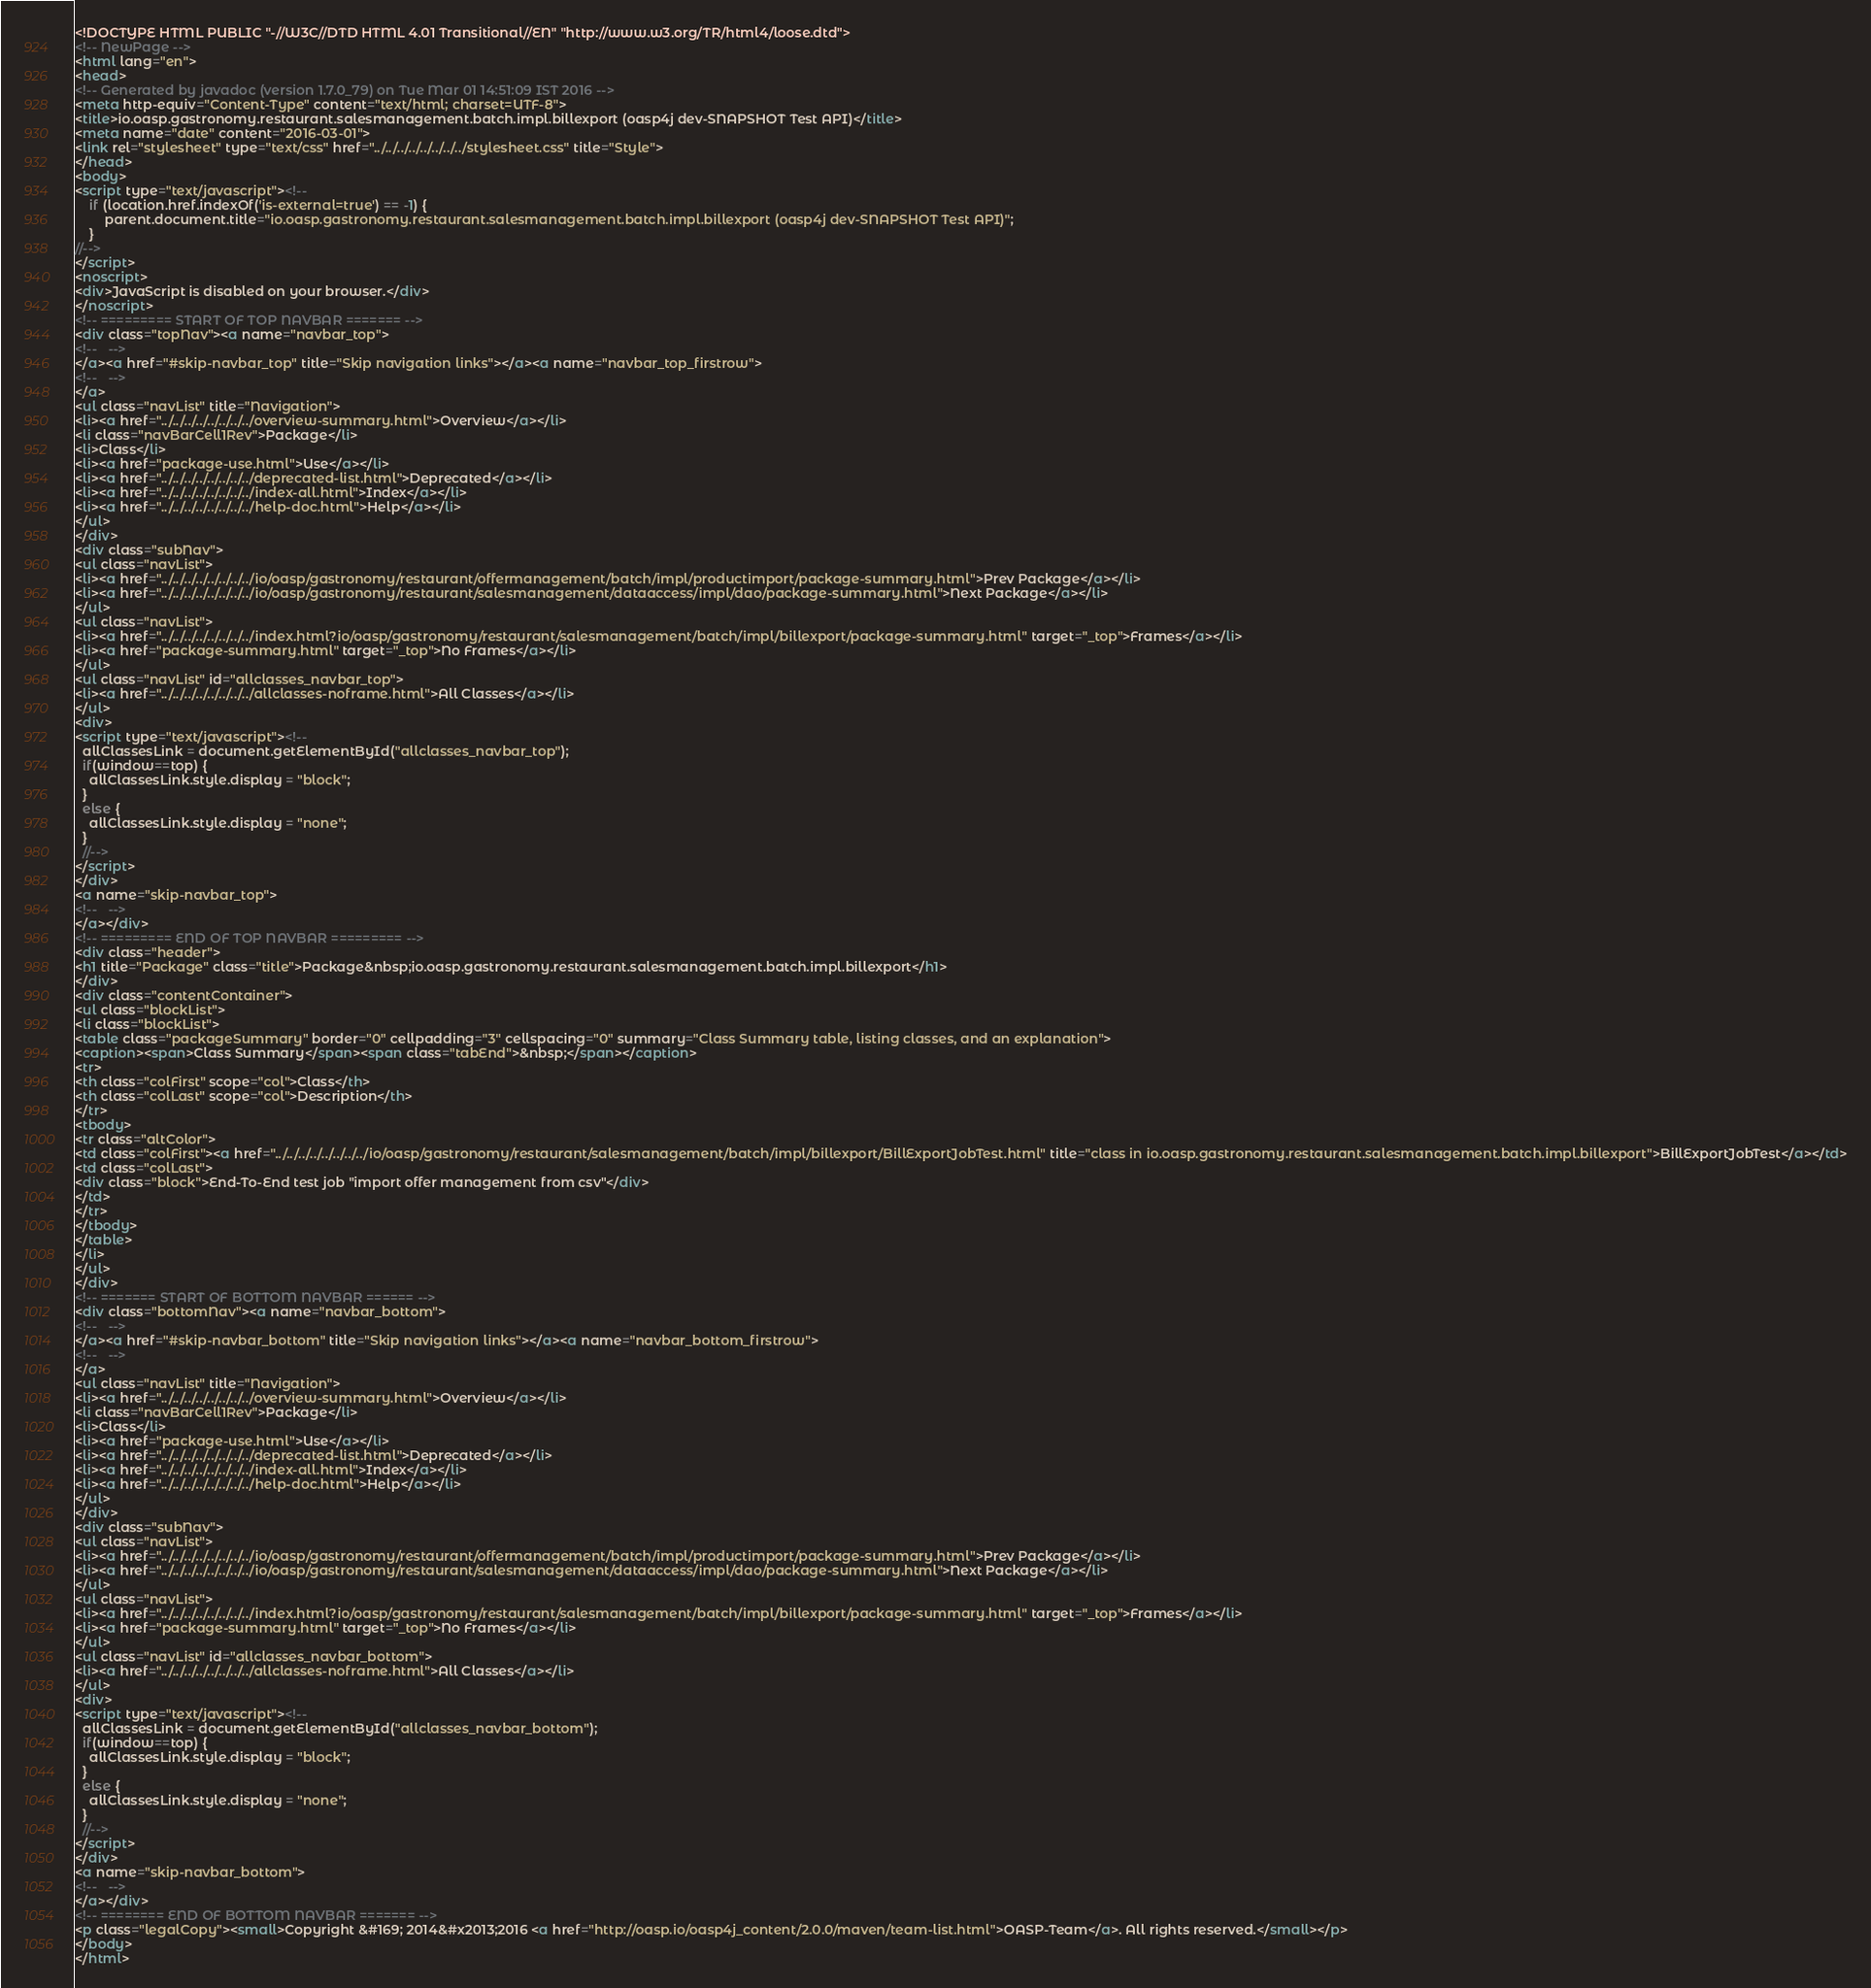<code> <loc_0><loc_0><loc_500><loc_500><_HTML_><!DOCTYPE HTML PUBLIC "-//W3C//DTD HTML 4.01 Transitional//EN" "http://www.w3.org/TR/html4/loose.dtd">
<!-- NewPage -->
<html lang="en">
<head>
<!-- Generated by javadoc (version 1.7.0_79) on Tue Mar 01 14:51:09 IST 2016 -->
<meta http-equiv="Content-Type" content="text/html; charset=UTF-8">
<title>io.oasp.gastronomy.restaurant.salesmanagement.batch.impl.billexport (oasp4j dev-SNAPSHOT Test API)</title>
<meta name="date" content="2016-03-01">
<link rel="stylesheet" type="text/css" href="../../../../../../../../stylesheet.css" title="Style">
</head>
<body>
<script type="text/javascript"><!--
    if (location.href.indexOf('is-external=true') == -1) {
        parent.document.title="io.oasp.gastronomy.restaurant.salesmanagement.batch.impl.billexport (oasp4j dev-SNAPSHOT Test API)";
    }
//-->
</script>
<noscript>
<div>JavaScript is disabled on your browser.</div>
</noscript>
<!-- ========= START OF TOP NAVBAR ======= -->
<div class="topNav"><a name="navbar_top">
<!--   -->
</a><a href="#skip-navbar_top" title="Skip navigation links"></a><a name="navbar_top_firstrow">
<!--   -->
</a>
<ul class="navList" title="Navigation">
<li><a href="../../../../../../../../overview-summary.html">Overview</a></li>
<li class="navBarCell1Rev">Package</li>
<li>Class</li>
<li><a href="package-use.html">Use</a></li>
<li><a href="../../../../../../../../deprecated-list.html">Deprecated</a></li>
<li><a href="../../../../../../../../index-all.html">Index</a></li>
<li><a href="../../../../../../../../help-doc.html">Help</a></li>
</ul>
</div>
<div class="subNav">
<ul class="navList">
<li><a href="../../../../../../../../io/oasp/gastronomy/restaurant/offermanagement/batch/impl/productimport/package-summary.html">Prev Package</a></li>
<li><a href="../../../../../../../../io/oasp/gastronomy/restaurant/salesmanagement/dataaccess/impl/dao/package-summary.html">Next Package</a></li>
</ul>
<ul class="navList">
<li><a href="../../../../../../../../index.html?io/oasp/gastronomy/restaurant/salesmanagement/batch/impl/billexport/package-summary.html" target="_top">Frames</a></li>
<li><a href="package-summary.html" target="_top">No Frames</a></li>
</ul>
<ul class="navList" id="allclasses_navbar_top">
<li><a href="../../../../../../../../allclasses-noframe.html">All Classes</a></li>
</ul>
<div>
<script type="text/javascript"><!--
  allClassesLink = document.getElementById("allclasses_navbar_top");
  if(window==top) {
    allClassesLink.style.display = "block";
  }
  else {
    allClassesLink.style.display = "none";
  }
  //-->
</script>
</div>
<a name="skip-navbar_top">
<!--   -->
</a></div>
<!-- ========= END OF TOP NAVBAR ========= -->
<div class="header">
<h1 title="Package" class="title">Package&nbsp;io.oasp.gastronomy.restaurant.salesmanagement.batch.impl.billexport</h1>
</div>
<div class="contentContainer">
<ul class="blockList">
<li class="blockList">
<table class="packageSummary" border="0" cellpadding="3" cellspacing="0" summary="Class Summary table, listing classes, and an explanation">
<caption><span>Class Summary</span><span class="tabEnd">&nbsp;</span></caption>
<tr>
<th class="colFirst" scope="col">Class</th>
<th class="colLast" scope="col">Description</th>
</tr>
<tbody>
<tr class="altColor">
<td class="colFirst"><a href="../../../../../../../../io/oasp/gastronomy/restaurant/salesmanagement/batch/impl/billexport/BillExportJobTest.html" title="class in io.oasp.gastronomy.restaurant.salesmanagement.batch.impl.billexport">BillExportJobTest</a></td>
<td class="colLast">
<div class="block">End-To-End test job "import offer management from csv"</div>
</td>
</tr>
</tbody>
</table>
</li>
</ul>
</div>
<!-- ======= START OF BOTTOM NAVBAR ====== -->
<div class="bottomNav"><a name="navbar_bottom">
<!--   -->
</a><a href="#skip-navbar_bottom" title="Skip navigation links"></a><a name="navbar_bottom_firstrow">
<!--   -->
</a>
<ul class="navList" title="Navigation">
<li><a href="../../../../../../../../overview-summary.html">Overview</a></li>
<li class="navBarCell1Rev">Package</li>
<li>Class</li>
<li><a href="package-use.html">Use</a></li>
<li><a href="../../../../../../../../deprecated-list.html">Deprecated</a></li>
<li><a href="../../../../../../../../index-all.html">Index</a></li>
<li><a href="../../../../../../../../help-doc.html">Help</a></li>
</ul>
</div>
<div class="subNav">
<ul class="navList">
<li><a href="../../../../../../../../io/oasp/gastronomy/restaurant/offermanagement/batch/impl/productimport/package-summary.html">Prev Package</a></li>
<li><a href="../../../../../../../../io/oasp/gastronomy/restaurant/salesmanagement/dataaccess/impl/dao/package-summary.html">Next Package</a></li>
</ul>
<ul class="navList">
<li><a href="../../../../../../../../index.html?io/oasp/gastronomy/restaurant/salesmanagement/batch/impl/billexport/package-summary.html" target="_top">Frames</a></li>
<li><a href="package-summary.html" target="_top">No Frames</a></li>
</ul>
<ul class="navList" id="allclasses_navbar_bottom">
<li><a href="../../../../../../../../allclasses-noframe.html">All Classes</a></li>
</ul>
<div>
<script type="text/javascript"><!--
  allClassesLink = document.getElementById("allclasses_navbar_bottom");
  if(window==top) {
    allClassesLink.style.display = "block";
  }
  else {
    allClassesLink.style.display = "none";
  }
  //-->
</script>
</div>
<a name="skip-navbar_bottom">
<!--   -->
</a></div>
<!-- ======== END OF BOTTOM NAVBAR ======= -->
<p class="legalCopy"><small>Copyright &#169; 2014&#x2013;2016 <a href="http://oasp.io/oasp4j_content/2.0.0/maven/team-list.html">OASP-Team</a>. All rights reserved.</small></p>
</body>
</html>
</code> 